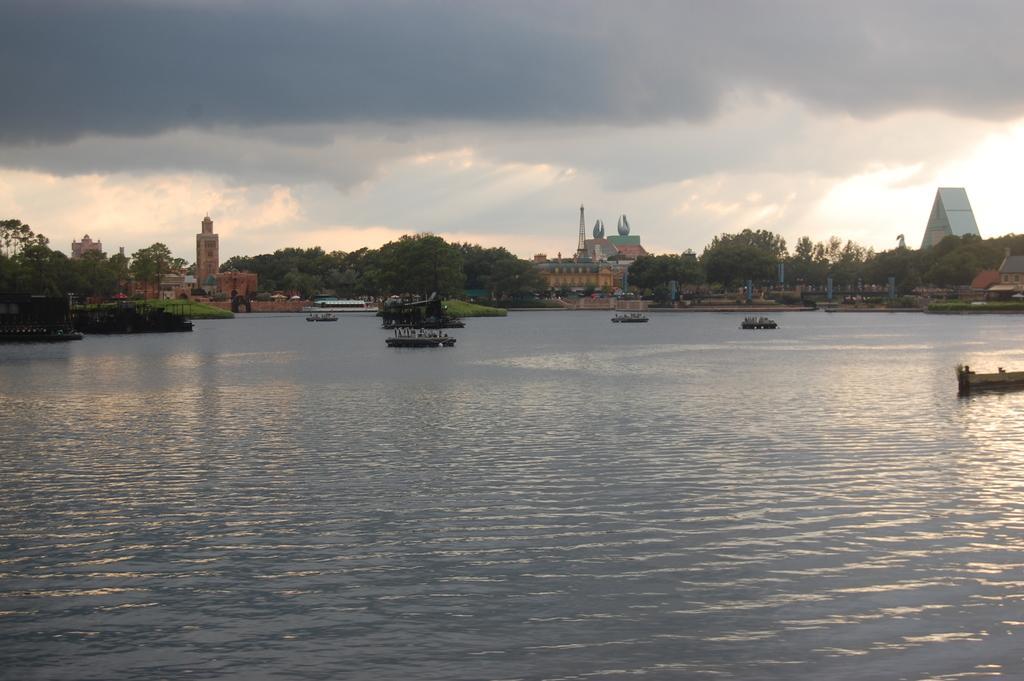Please provide a concise description of this image. In this image, we can see boats on the water and in the background, there are trees, buildings, towers and poles. At the top, there are clouds in the sky. 